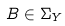<formula> <loc_0><loc_0><loc_500><loc_500>B \in \Sigma _ { Y }</formula> 